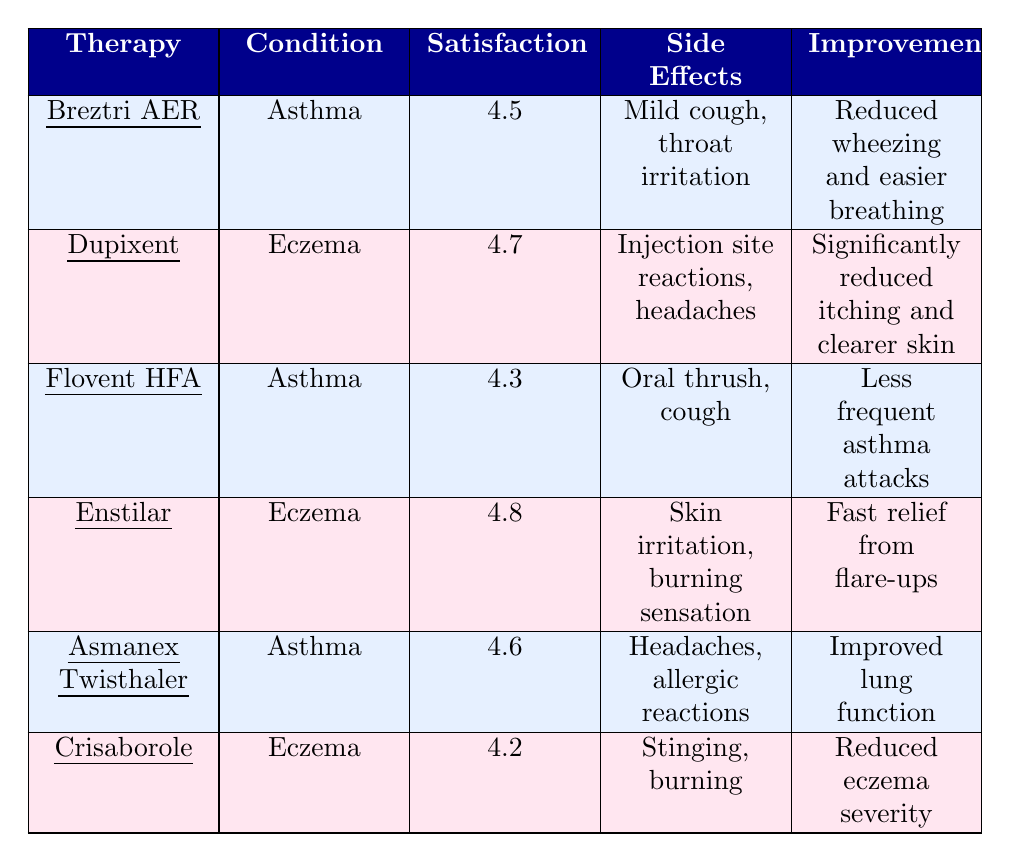What is the satisfaction rating for Dupixent? According to the table, the satisfaction rating for Dupixent, which is used for eczema, is specifically listed as 4.7.
Answer: 4.7 Which therapy has the highest satisfaction rating? By looking at the satisfaction ratings in the table, the highest rating is found next to Enstilar, which has a rating of 4.8.
Answer: 4.8 What are the side effects of Breztri AER? The table lists the side effects of Breztri AER as mild cough and throat irritation.
Answer: Mild cough, throat irritation Does Crisaborole have a higher satisfaction rating than Flovent HFA? Crisaborole has a satisfaction rating of 4.2 while Flovent HFA has a rating of 4.3. Since 4.2 is less than 4.3, Crisaborole does not have a higher rating.
Answer: No What is the average satisfaction rating for asthma therapies? The satisfaction ratings for asthma therapies are 4.5 (Breztri AER), 4.3 (Flovent HFA), and 4.6 (Asmanex Twisthaler). The average is calculated as (4.5 + 4.3 + 4.6) / 3 = 4.4667, rounded to 4.47.
Answer: 4.47 How many asthma therapies are listed in the table? The table provides three asthma therapies: Breztri AER, Flovent HFA, and Asmanex Twisthaler. Therefore, there are three listed.
Answer: 3 Which therapy provides fast relief from flare-ups? The table indicates that Enstilar provides fast relief from flare-ups, which is its improvement noted in the data.
Answer: Enstilar Is there any therapy that received a satisfaction rating below 4.3? Looking at the satisfaction ratings, Crisaborole has a rating of 4.2, which is indeed below 4.3. So the answer is yes.
Answer: Yes How many therapies listed have a satisfaction rating of 4.5 or higher? The therapies with ratings of 4.5 or higher are Breztri AER (4.5), Dupixent (4.7), Enstilar (4.8), and Asmanex Twisthaler (4.6). So there are four therapies in total.
Answer: 4 Which eczema therapy has a lower satisfaction rating: Crisaborole or Dupixent? Crisaborole has a satisfaction rating of 4.2 while Dupixent has a rating of 4.7. Therefore, Crisaborole has the lower rating.
Answer: Crisaborole 